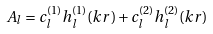Convert formula to latex. <formula><loc_0><loc_0><loc_500><loc_500>A _ { l } = { c _ { l } ^ { ( 1 ) } } { h _ { l } ^ { ( 1 ) } } ( k r ) + { c _ { l } ^ { ( 2 ) } } { h _ { l } ^ { ( 2 ) } } ( k r )</formula> 